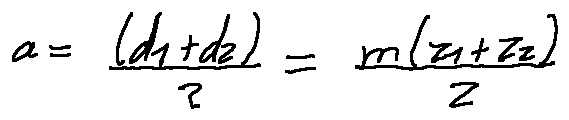Convert formula to latex. <formula><loc_0><loc_0><loc_500><loc_500>a = \frac { ( d _ { 1 } + d _ { 2 } ) } { 2 } = \frac { m ( z _ { 1 } + z _ { 2 } ) } { 2 }</formula> 